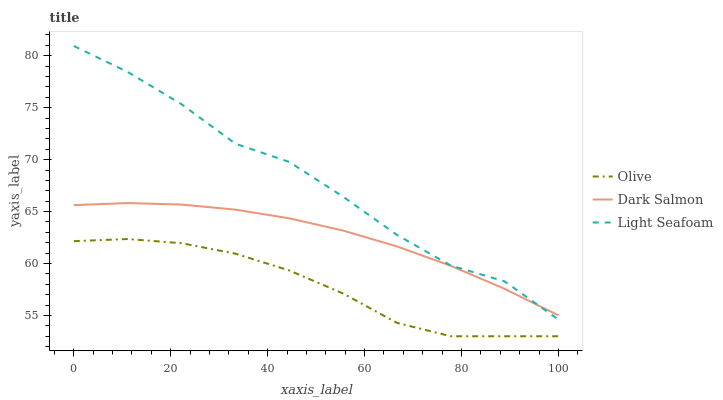Does Olive have the minimum area under the curve?
Answer yes or no. Yes. Does Light Seafoam have the maximum area under the curve?
Answer yes or no. Yes. Does Dark Salmon have the minimum area under the curve?
Answer yes or no. No. Does Dark Salmon have the maximum area under the curve?
Answer yes or no. No. Is Dark Salmon the smoothest?
Answer yes or no. Yes. Is Light Seafoam the roughest?
Answer yes or no. Yes. Is Light Seafoam the smoothest?
Answer yes or no. No. Is Dark Salmon the roughest?
Answer yes or no. No. Does Olive have the lowest value?
Answer yes or no. Yes. Does Light Seafoam have the lowest value?
Answer yes or no. No. Does Light Seafoam have the highest value?
Answer yes or no. Yes. Does Dark Salmon have the highest value?
Answer yes or no. No. Is Olive less than Dark Salmon?
Answer yes or no. Yes. Is Dark Salmon greater than Olive?
Answer yes or no. Yes. Does Dark Salmon intersect Light Seafoam?
Answer yes or no. Yes. Is Dark Salmon less than Light Seafoam?
Answer yes or no. No. Is Dark Salmon greater than Light Seafoam?
Answer yes or no. No. Does Olive intersect Dark Salmon?
Answer yes or no. No. 